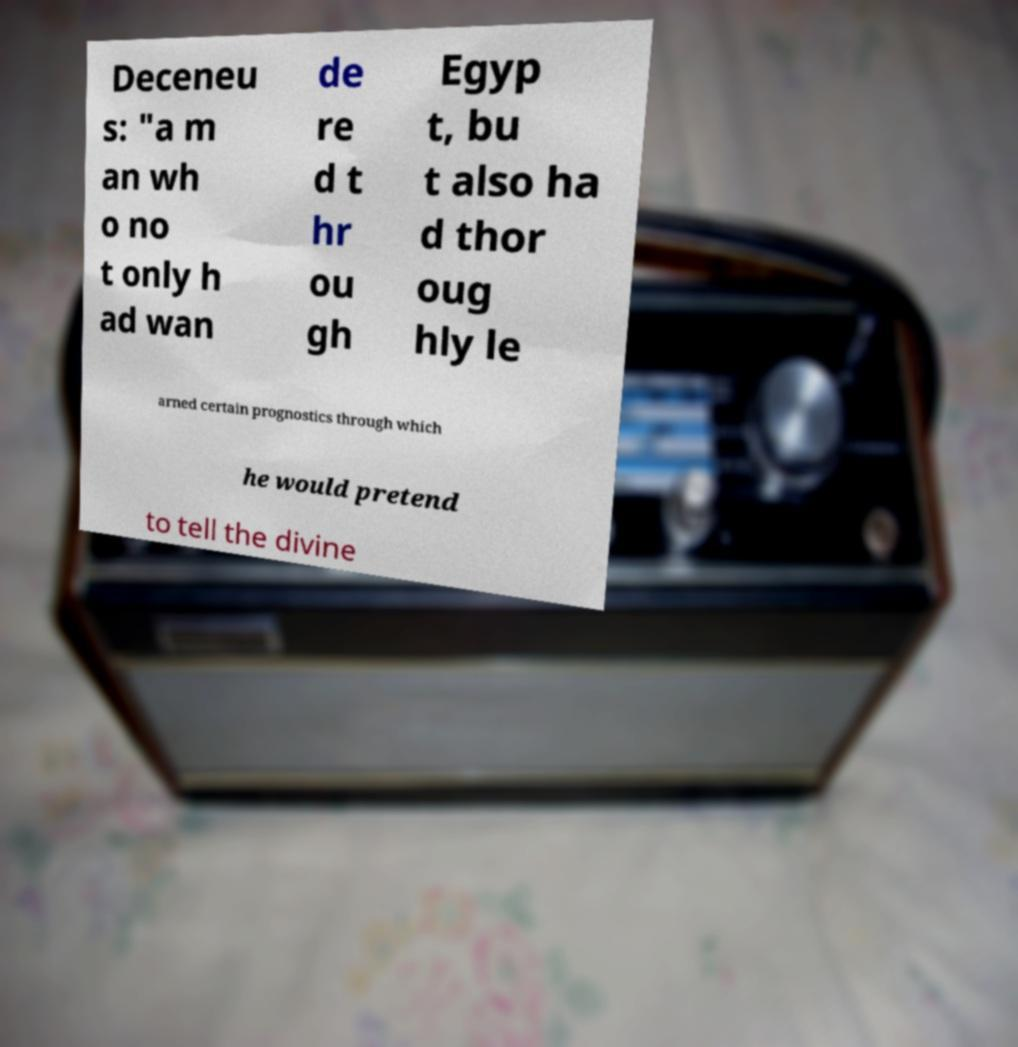I need the written content from this picture converted into text. Can you do that? Deceneu s: "a m an wh o no t only h ad wan de re d t hr ou gh Egyp t, bu t also ha d thor oug hly le arned certain prognostics through which he would pretend to tell the divine 